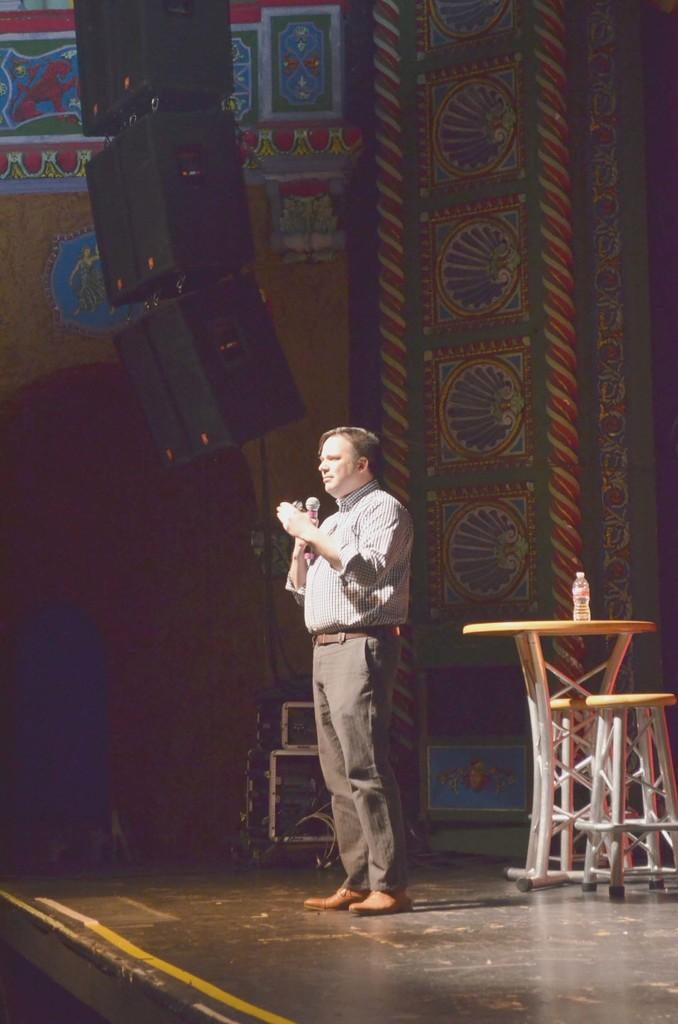What is the person in the image holding? The person is holding a microphone in the image. Where is the person standing? The person is standing on a stage in the image. What other objects are on the stage? There is a chair, a table, and a bottle on the stage. What can be used for amplifying sound in the image? There are speakers in the image. What is the background of the stage like? There is a designed wall in the image. How does the wind affect the person holding the microphone in the image? There is no wind present in the image, so it does not affect the person holding the microphone. 